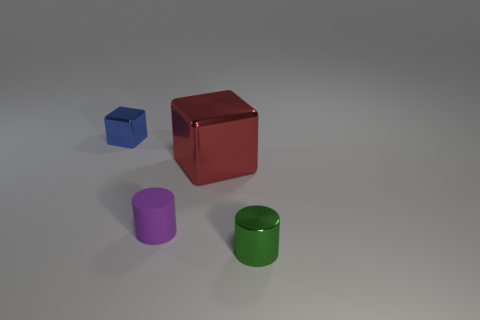What number of other green things are the same shape as the small green metal thing?
Make the answer very short. 0. There is a blue thing that is the same material as the tiny green cylinder; what size is it?
Make the answer very short. Small. The shiny block that is in front of the block that is to the left of the large red block is what color?
Give a very brief answer. Red. Does the tiny matte object have the same shape as the small object that is behind the purple cylinder?
Provide a short and direct response. No. What number of rubber things have the same size as the red cube?
Keep it short and to the point. 0. There is a small blue object that is the same shape as the red shiny object; what material is it?
Your answer should be very brief. Metal. Does the cube that is behind the big block have the same color as the cylinder that is behind the tiny metallic cylinder?
Keep it short and to the point. No. There is a small object that is behind the small purple matte cylinder; what is its shape?
Offer a terse response. Cube. The matte thing has what color?
Your answer should be very brief. Purple. There is a green thing that is made of the same material as the small cube; what shape is it?
Give a very brief answer. Cylinder. 